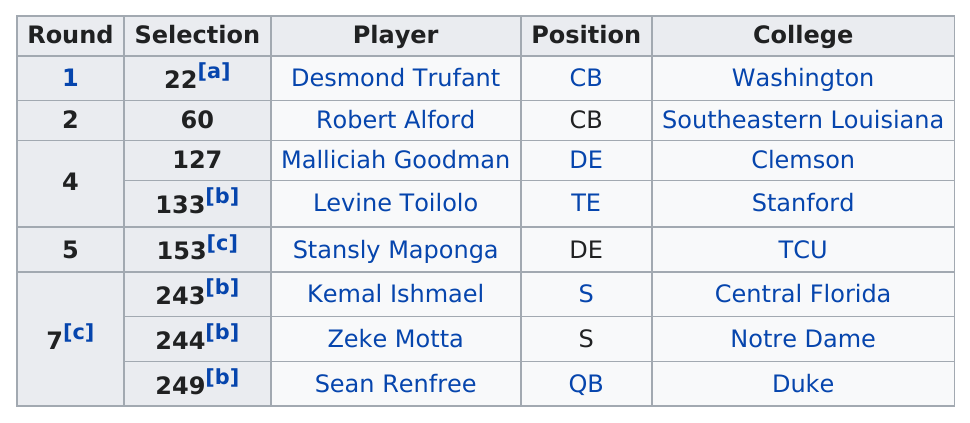Give some essential details in this illustration. Desmond Trufant was the top draft pick. Eight different colleges were represented by the players. If you were to add all of the selection numbers together, the total would be 1231. The top-listed player is Desmond Trufant. A total of three players share the same position type. 